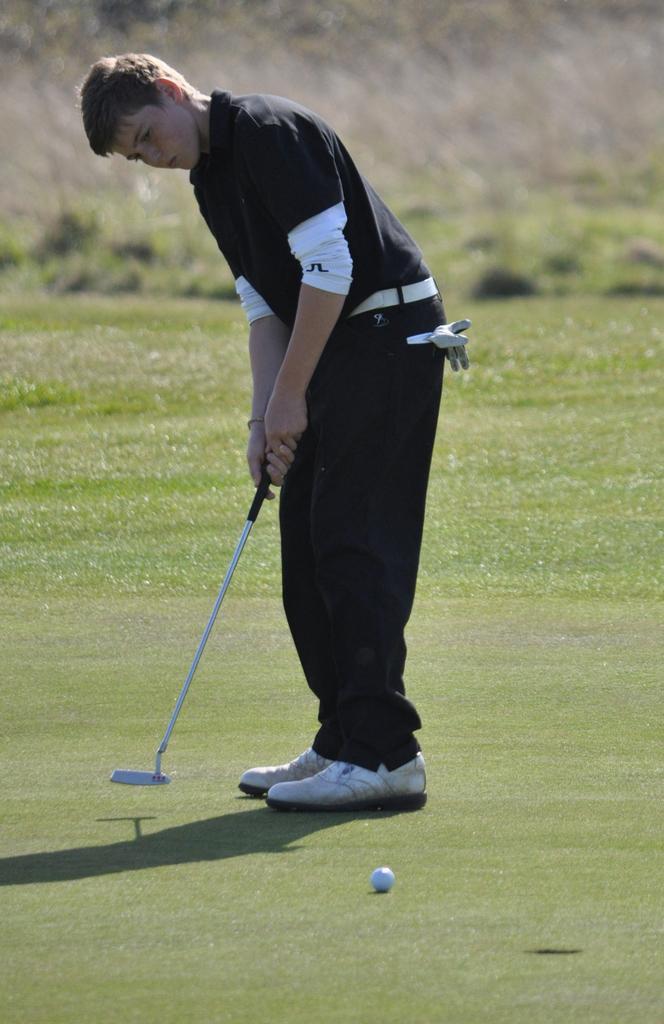Could you give a brief overview of what you see in this image? In this image we can see a person standing and holding a golf bat. At the bottom there is a ball. 